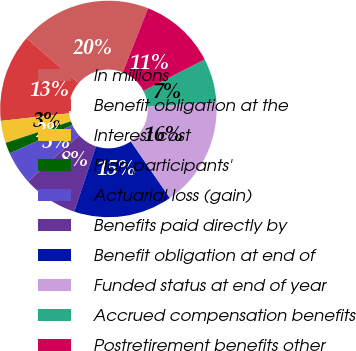<chart> <loc_0><loc_0><loc_500><loc_500><pie_chart><fcel>In millions<fcel>Benefit obligation at the<fcel>Interest cost<fcel>Plan participants'<fcel>Actuarial loss (gain)<fcel>Benefits paid directly by<fcel>Benefit obligation at end of<fcel>Funded status at end of year<fcel>Accrued compensation benefits<fcel>Postretirement benefits other<nl><fcel>19.63%<fcel>13.1%<fcel>3.31%<fcel>1.67%<fcel>4.94%<fcel>8.2%<fcel>14.73%<fcel>16.37%<fcel>6.57%<fcel>11.47%<nl></chart> 